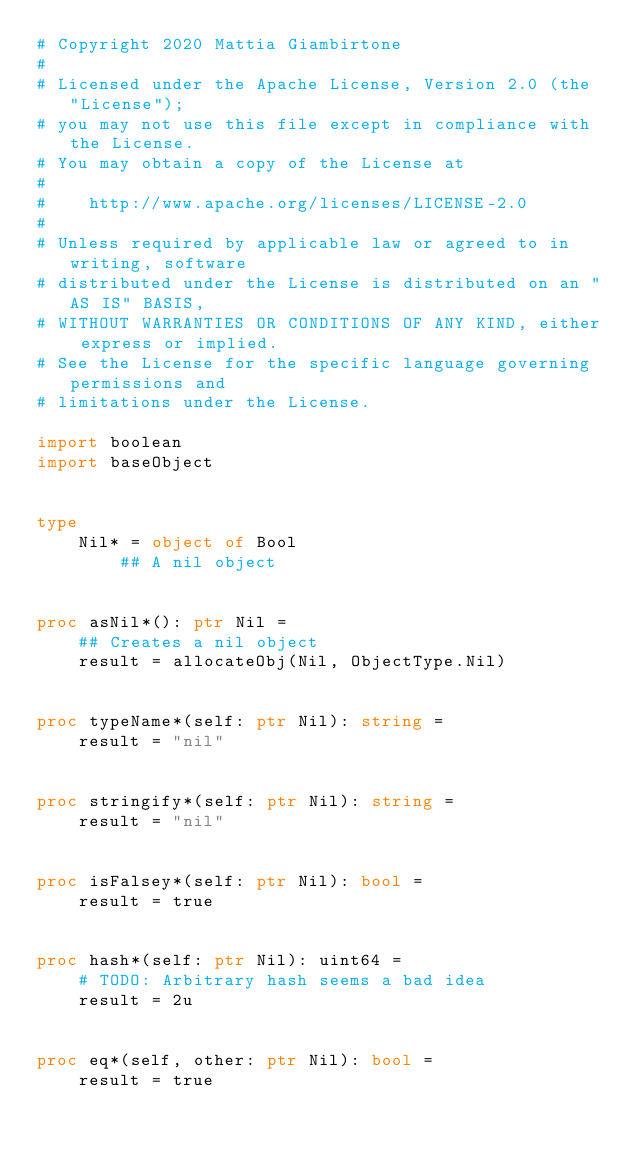Convert code to text. <code><loc_0><loc_0><loc_500><loc_500><_Nim_># Copyright 2020 Mattia Giambirtone
#
# Licensed under the Apache License, Version 2.0 (the "License");
# you may not use this file except in compliance with the License.
# You may obtain a copy of the License at
#
#    http://www.apache.org/licenses/LICENSE-2.0
#
# Unless required by applicable law or agreed to in writing, software
# distributed under the License is distributed on an "AS IS" BASIS,
# WITHOUT WARRANTIES OR CONDITIONS OF ANY KIND, either express or implied.
# See the License for the specific language governing permissions and
# limitations under the License.

import boolean
import baseObject


type
    Nil* = object of Bool
        ## A nil object


proc asNil*(): ptr Nil =
    ## Creates a nil object
    result = allocateObj(Nil, ObjectType.Nil)


proc typeName*(self: ptr Nil): string =
    result = "nil"


proc stringify*(self: ptr Nil): string =
    result = "nil"


proc isFalsey*(self: ptr Nil): bool =
    result = true


proc hash*(self: ptr Nil): uint64 =
    # TODO: Arbitrary hash seems a bad idea
    result = 2u


proc eq*(self, other: ptr Nil): bool =
    result = true



</code> 